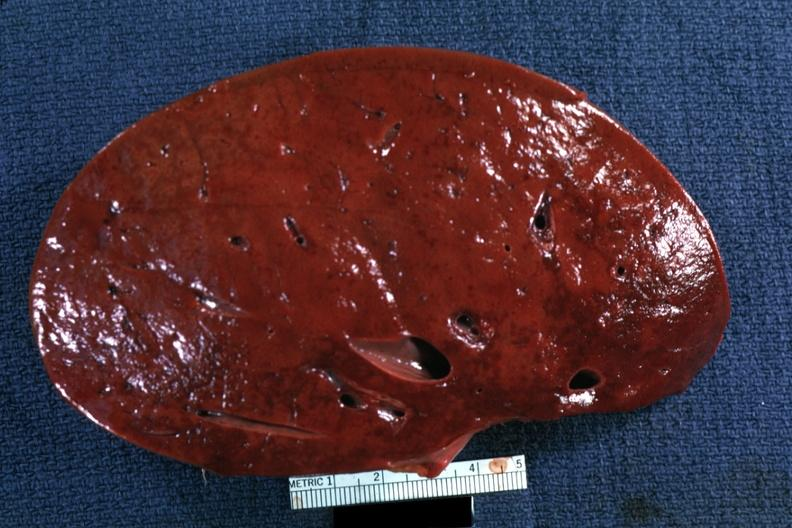s spleen present?
Answer the question using a single word or phrase. Yes 